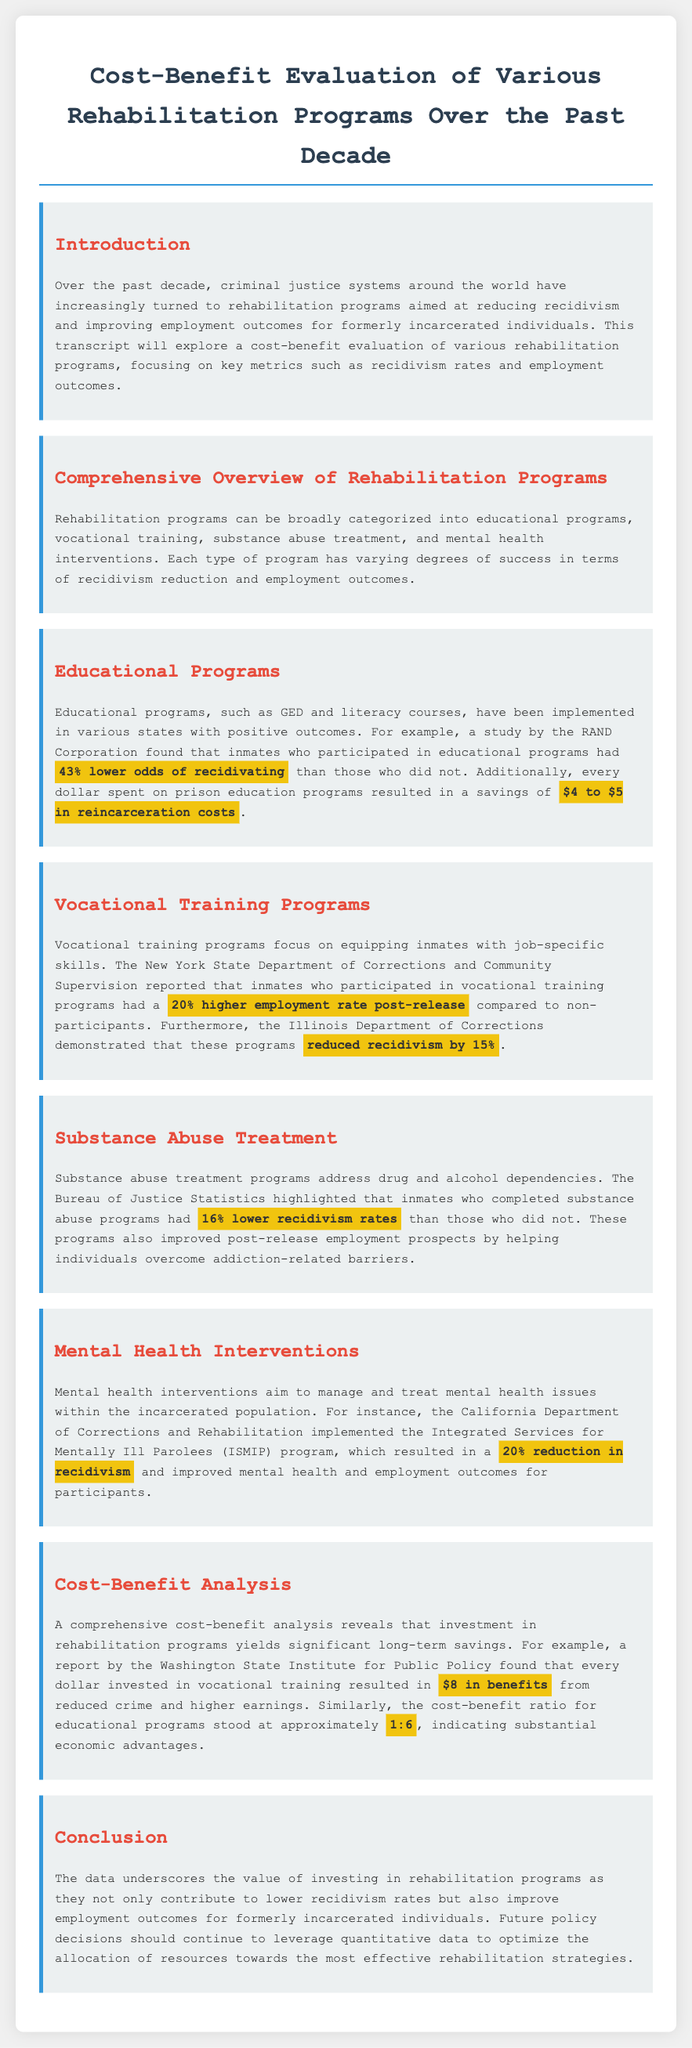what is the percentage lower odds of recidivating for participants in educational programs? The document states that inmates who participated in educational programs had 43% lower odds of recidivating compared to those who did not.
Answer: 43% what is the savings in reincarceration costs for every dollar spent on prison education programs? The document indicates that every dollar spent on prison education programs resulted in a savings of $4 to $5 in reincarceration costs.
Answer: $4 to $5 how much higher is the employment rate for inmates who took vocational training programs? According to the document, inmates who participated in vocational training programs had a 20% higher employment rate post-release compared to non-participants.
Answer: 20% what is the reduction in recidivism rates for inmates who completed substance abuse treatment? The document highlights that inmates who completed substance abuse programs had 16% lower recidivism rates than those who did not.
Answer: 16% what is the cost-benefit ratio for educational programs mentioned in the document? The document states that the cost-benefit ratio for educational programs stood at approximately 1:6, indicating substantial economic advantages.
Answer: 1:6 what program demonstrated a 20% reduction in recidivism related to mental health? The Integrated Services for Mentally Ill Parolees (ISMIP) program, as mentioned in the document, resulted in a 20% reduction in recidivism.
Answer: ISMIP what is the total benefit from every dollar invested in vocational training? The document notes that every dollar invested in vocational training resulted in $8 in benefits from reduced crime and higher earnings.
Answer: $8 what types of rehabilitation programs are mentioned in the document? The document mentions educational programs, vocational training, substance abuse treatment, and mental health interventions as types of rehabilitation programs.
Answer: educational programs, vocational training, substance abuse treatment, mental health interventions 